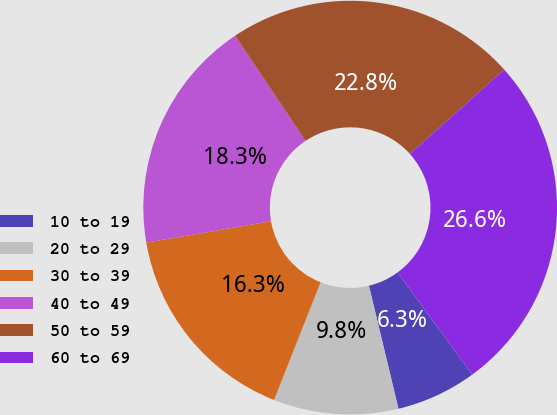Convert chart to OTSL. <chart><loc_0><loc_0><loc_500><loc_500><pie_chart><fcel>10 to 19<fcel>20 to 29<fcel>30 to 39<fcel>40 to 49<fcel>50 to 59<fcel>60 to 69<nl><fcel>6.29%<fcel>9.75%<fcel>16.29%<fcel>18.32%<fcel>22.75%<fcel>26.59%<nl></chart> 